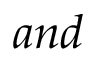<formula> <loc_0><loc_0><loc_500><loc_500>a n d</formula> 